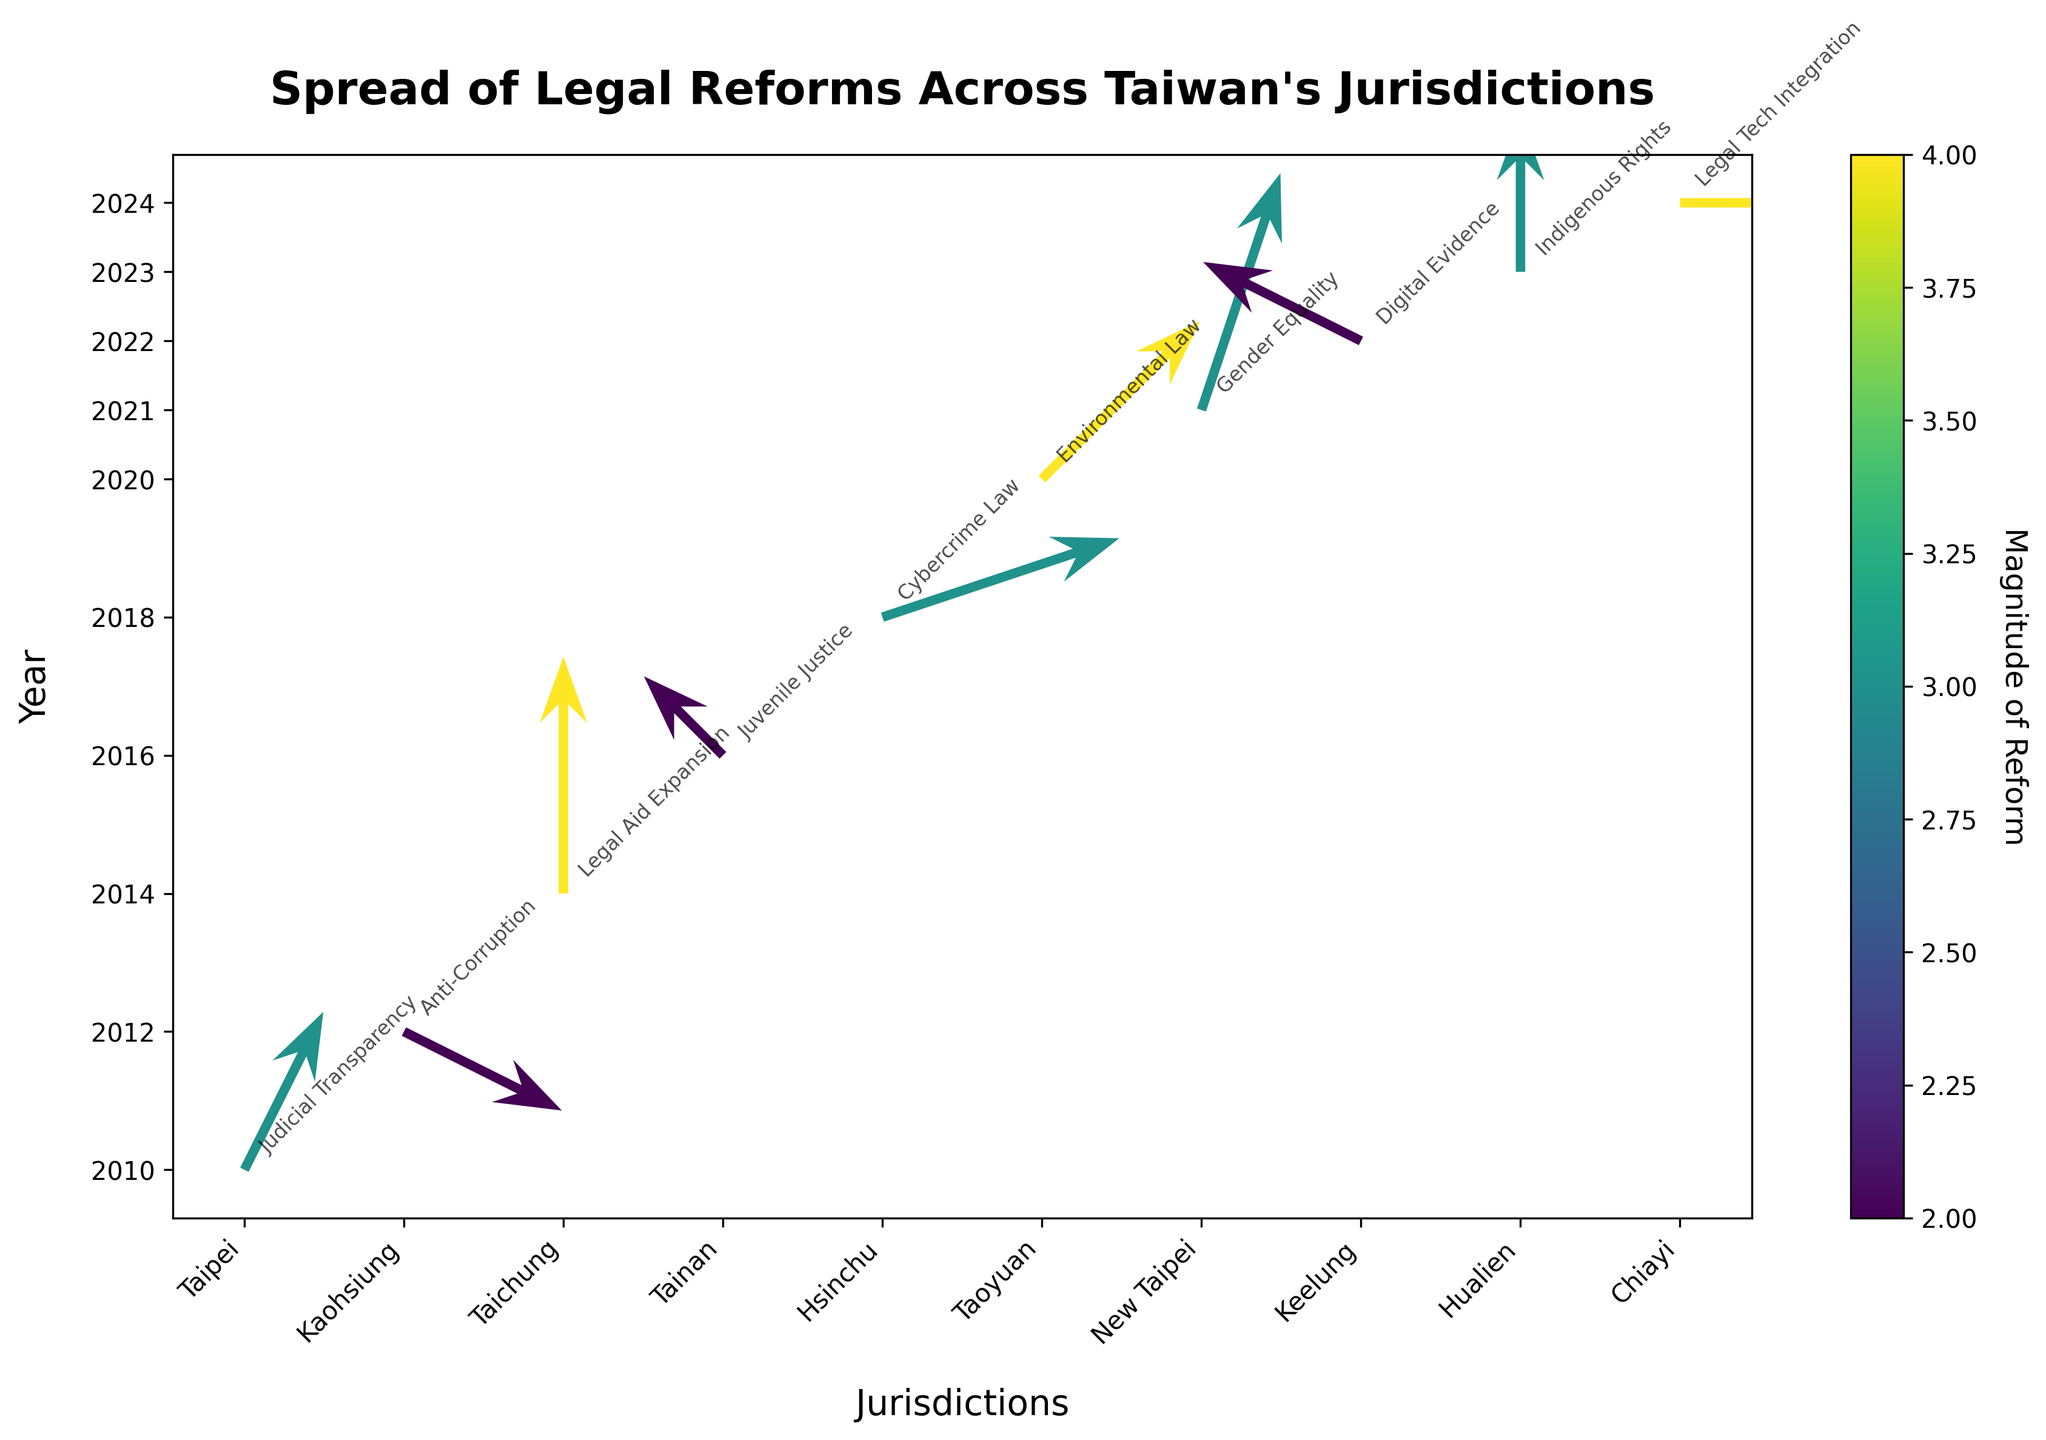What is the title of the figure? The title is located at the top of the figure and is typically in a larger font size than other text.
Answer: Spread of Legal Reforms Across Taiwan's Jurisdictions How many different jurisdictions are represented in the figure? Count the number of distinct jurisdictions labeled along the x-axis. Each tick represents a unique jurisdiction.
Answer: 10 Which year corresponds to the longest reform vector? Locate the longest arrow in the figure (most visually prominent) and trace it back to its point of origin on the y-axis, which represents the year.
Answer: 2014 What is the direction of the reform vector for Kaohsiung in 2012? Focus on the reform vector that originates from Kaohsiung in 2012. The x direction is represented by the horizontal component, and the y direction by the vertical component of the arrow.
Answer: (2, -1) Which reform type occurred in Hualien and what year? Find the reform vector starting from Hualien on the x-axis and trace it back to the y-axis for the year. The reform type is often annotated near the arrow.
Answer: Indigenous Rights in 2023 Compare the magnitude of reforms between Taipei 2010 and New Taipei 2021. Which one is larger? Check the color intensity of the arrows starting from Taipei 2010 and New Taipei 2021. The color bar indicates the magnitude, with the shade intensity corresponding to the reform strength.
Answer: New Taipei 2021 What is the average magnitude of reforms that occurred in 2020, 2021, and 2022? Note the magnitudes from 2020 (4), 2021 (3), and 2022 (2). Sum them up and divide by the number of years (3).
Answer: (4 + 3 + 2) / 3 = 3 Which jurisdiction experienced a reform moving strongly in the positive x direction and what was the reform type? Identify the arrow moving mostly to the right (positive x direction). Check the x values and the annotation explaining the reform type.
Answer: Chiayi with Legal Tech Integration How is the reform in Tainan in 2016 oriented? Observe the reform vector originating from Tainan in 2016. The direction is determined by the arrow's coordinates in the x and y axes.
Answer: (-1, 1) Which two jurisdictions had reforms in 2018 and 2024, and were they more oriented vertically or horizontally? Look for the reforms originating in 2018 and 2024. Check the direction vector's components to decide the orientation by comparing their x and y directions.
Answer: Hsinchu 2018 (more vertical), Chiayi 2024 (more horizontal) 